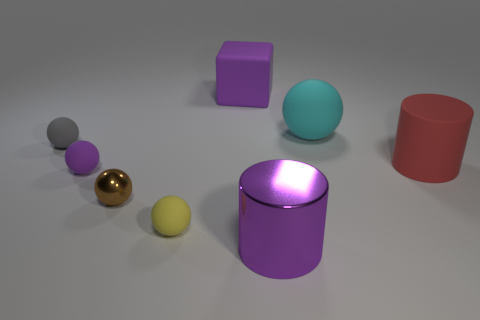Subtract all tiny yellow spheres. How many spheres are left? 4 Subtract all purple spheres. How many spheres are left? 4 Subtract all brown spheres. Subtract all blue cylinders. How many spheres are left? 4 Add 1 tiny yellow rubber spheres. How many objects exist? 9 Subtract all cubes. How many objects are left? 7 Subtract all small purple balls. Subtract all big purple shiny things. How many objects are left? 6 Add 2 shiny balls. How many shiny balls are left? 3 Add 1 tiny things. How many tiny things exist? 5 Subtract 0 green cylinders. How many objects are left? 8 